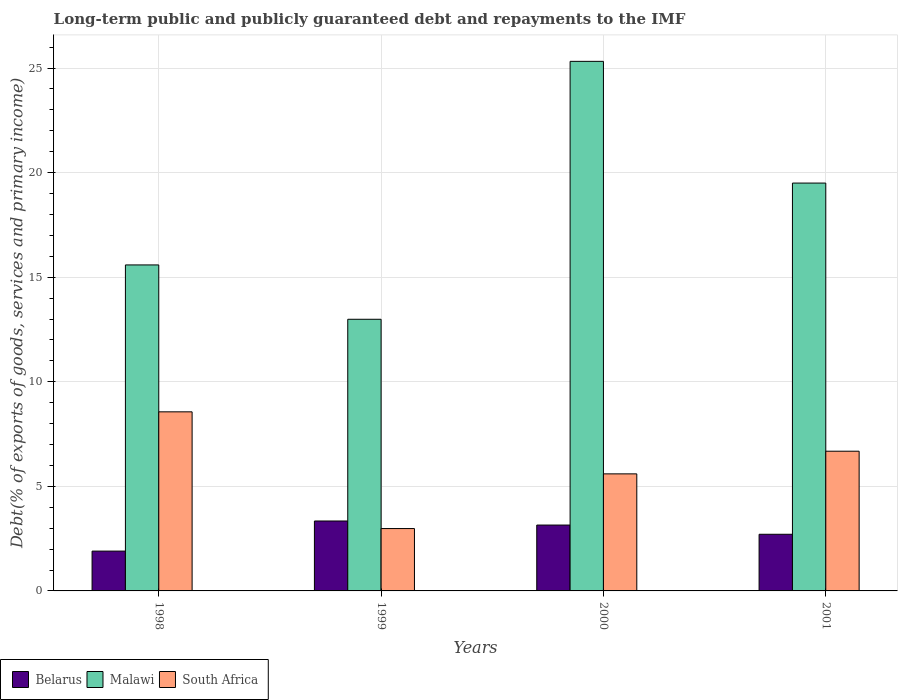How many different coloured bars are there?
Keep it short and to the point. 3. How many groups of bars are there?
Offer a terse response. 4. Are the number of bars per tick equal to the number of legend labels?
Make the answer very short. Yes. In how many cases, is the number of bars for a given year not equal to the number of legend labels?
Offer a very short reply. 0. What is the debt and repayments in South Africa in 2001?
Give a very brief answer. 6.68. Across all years, what is the maximum debt and repayments in Malawi?
Ensure brevity in your answer.  25.32. Across all years, what is the minimum debt and repayments in Belarus?
Keep it short and to the point. 1.9. In which year was the debt and repayments in South Africa maximum?
Give a very brief answer. 1998. What is the total debt and repayments in South Africa in the graph?
Keep it short and to the point. 23.82. What is the difference between the debt and repayments in South Africa in 1999 and that in 2001?
Ensure brevity in your answer.  -3.7. What is the difference between the debt and repayments in South Africa in 2000 and the debt and repayments in Malawi in 2001?
Make the answer very short. -13.9. What is the average debt and repayments in Belarus per year?
Offer a very short reply. 2.78. In the year 2001, what is the difference between the debt and repayments in South Africa and debt and repayments in Malawi?
Your answer should be very brief. -12.82. What is the ratio of the debt and repayments in Malawi in 2000 to that in 2001?
Offer a very short reply. 1.3. Is the difference between the debt and repayments in South Africa in 1999 and 2000 greater than the difference between the debt and repayments in Malawi in 1999 and 2000?
Provide a succinct answer. Yes. What is the difference between the highest and the second highest debt and repayments in Malawi?
Provide a short and direct response. 5.82. What is the difference between the highest and the lowest debt and repayments in Belarus?
Your answer should be compact. 1.44. What does the 3rd bar from the left in 2001 represents?
Your response must be concise. South Africa. What does the 3rd bar from the right in 1999 represents?
Ensure brevity in your answer.  Belarus. How many bars are there?
Offer a terse response. 12. How are the legend labels stacked?
Offer a terse response. Horizontal. What is the title of the graph?
Your response must be concise. Long-term public and publicly guaranteed debt and repayments to the IMF. What is the label or title of the X-axis?
Offer a terse response. Years. What is the label or title of the Y-axis?
Offer a very short reply. Debt(% of exports of goods, services and primary income). What is the Debt(% of exports of goods, services and primary income) of Belarus in 1998?
Your answer should be very brief. 1.9. What is the Debt(% of exports of goods, services and primary income) of Malawi in 1998?
Give a very brief answer. 15.59. What is the Debt(% of exports of goods, services and primary income) in South Africa in 1998?
Your answer should be very brief. 8.56. What is the Debt(% of exports of goods, services and primary income) of Belarus in 1999?
Provide a succinct answer. 3.34. What is the Debt(% of exports of goods, services and primary income) of Malawi in 1999?
Make the answer very short. 12.99. What is the Debt(% of exports of goods, services and primary income) of South Africa in 1999?
Provide a short and direct response. 2.98. What is the Debt(% of exports of goods, services and primary income) in Belarus in 2000?
Your answer should be compact. 3.15. What is the Debt(% of exports of goods, services and primary income) in Malawi in 2000?
Keep it short and to the point. 25.32. What is the Debt(% of exports of goods, services and primary income) in South Africa in 2000?
Your answer should be very brief. 5.6. What is the Debt(% of exports of goods, services and primary income) in Belarus in 2001?
Your answer should be very brief. 2.71. What is the Debt(% of exports of goods, services and primary income) of Malawi in 2001?
Provide a short and direct response. 19.5. What is the Debt(% of exports of goods, services and primary income) of South Africa in 2001?
Offer a terse response. 6.68. Across all years, what is the maximum Debt(% of exports of goods, services and primary income) in Belarus?
Keep it short and to the point. 3.34. Across all years, what is the maximum Debt(% of exports of goods, services and primary income) of Malawi?
Offer a terse response. 25.32. Across all years, what is the maximum Debt(% of exports of goods, services and primary income) in South Africa?
Make the answer very short. 8.56. Across all years, what is the minimum Debt(% of exports of goods, services and primary income) in Belarus?
Provide a succinct answer. 1.9. Across all years, what is the minimum Debt(% of exports of goods, services and primary income) of Malawi?
Offer a terse response. 12.99. Across all years, what is the minimum Debt(% of exports of goods, services and primary income) in South Africa?
Make the answer very short. 2.98. What is the total Debt(% of exports of goods, services and primary income) of Belarus in the graph?
Give a very brief answer. 11.11. What is the total Debt(% of exports of goods, services and primary income) of Malawi in the graph?
Give a very brief answer. 73.4. What is the total Debt(% of exports of goods, services and primary income) in South Africa in the graph?
Your response must be concise. 23.82. What is the difference between the Debt(% of exports of goods, services and primary income) of Belarus in 1998 and that in 1999?
Your answer should be compact. -1.44. What is the difference between the Debt(% of exports of goods, services and primary income) of Malawi in 1998 and that in 1999?
Your answer should be compact. 2.6. What is the difference between the Debt(% of exports of goods, services and primary income) in South Africa in 1998 and that in 1999?
Your answer should be very brief. 5.58. What is the difference between the Debt(% of exports of goods, services and primary income) of Belarus in 1998 and that in 2000?
Your answer should be compact. -1.25. What is the difference between the Debt(% of exports of goods, services and primary income) of Malawi in 1998 and that in 2000?
Your response must be concise. -9.73. What is the difference between the Debt(% of exports of goods, services and primary income) in South Africa in 1998 and that in 2000?
Offer a terse response. 2.97. What is the difference between the Debt(% of exports of goods, services and primary income) in Belarus in 1998 and that in 2001?
Your response must be concise. -0.8. What is the difference between the Debt(% of exports of goods, services and primary income) in Malawi in 1998 and that in 2001?
Your response must be concise. -3.91. What is the difference between the Debt(% of exports of goods, services and primary income) of South Africa in 1998 and that in 2001?
Your answer should be compact. 1.88. What is the difference between the Debt(% of exports of goods, services and primary income) of Belarus in 1999 and that in 2000?
Keep it short and to the point. 0.19. What is the difference between the Debt(% of exports of goods, services and primary income) of Malawi in 1999 and that in 2000?
Provide a short and direct response. -12.33. What is the difference between the Debt(% of exports of goods, services and primary income) of South Africa in 1999 and that in 2000?
Your answer should be very brief. -2.61. What is the difference between the Debt(% of exports of goods, services and primary income) of Belarus in 1999 and that in 2001?
Provide a short and direct response. 0.63. What is the difference between the Debt(% of exports of goods, services and primary income) in Malawi in 1999 and that in 2001?
Ensure brevity in your answer.  -6.51. What is the difference between the Debt(% of exports of goods, services and primary income) in South Africa in 1999 and that in 2001?
Your response must be concise. -3.7. What is the difference between the Debt(% of exports of goods, services and primary income) in Belarus in 2000 and that in 2001?
Offer a terse response. 0.44. What is the difference between the Debt(% of exports of goods, services and primary income) of Malawi in 2000 and that in 2001?
Keep it short and to the point. 5.82. What is the difference between the Debt(% of exports of goods, services and primary income) in South Africa in 2000 and that in 2001?
Provide a succinct answer. -1.08. What is the difference between the Debt(% of exports of goods, services and primary income) in Belarus in 1998 and the Debt(% of exports of goods, services and primary income) in Malawi in 1999?
Provide a short and direct response. -11.08. What is the difference between the Debt(% of exports of goods, services and primary income) in Belarus in 1998 and the Debt(% of exports of goods, services and primary income) in South Africa in 1999?
Your answer should be compact. -1.08. What is the difference between the Debt(% of exports of goods, services and primary income) of Malawi in 1998 and the Debt(% of exports of goods, services and primary income) of South Africa in 1999?
Offer a very short reply. 12.6. What is the difference between the Debt(% of exports of goods, services and primary income) of Belarus in 1998 and the Debt(% of exports of goods, services and primary income) of Malawi in 2000?
Provide a succinct answer. -23.42. What is the difference between the Debt(% of exports of goods, services and primary income) in Belarus in 1998 and the Debt(% of exports of goods, services and primary income) in South Africa in 2000?
Offer a terse response. -3.69. What is the difference between the Debt(% of exports of goods, services and primary income) in Malawi in 1998 and the Debt(% of exports of goods, services and primary income) in South Africa in 2000?
Make the answer very short. 9.99. What is the difference between the Debt(% of exports of goods, services and primary income) of Belarus in 1998 and the Debt(% of exports of goods, services and primary income) of Malawi in 2001?
Offer a terse response. -17.6. What is the difference between the Debt(% of exports of goods, services and primary income) of Belarus in 1998 and the Debt(% of exports of goods, services and primary income) of South Africa in 2001?
Keep it short and to the point. -4.78. What is the difference between the Debt(% of exports of goods, services and primary income) of Malawi in 1998 and the Debt(% of exports of goods, services and primary income) of South Africa in 2001?
Make the answer very short. 8.91. What is the difference between the Debt(% of exports of goods, services and primary income) of Belarus in 1999 and the Debt(% of exports of goods, services and primary income) of Malawi in 2000?
Keep it short and to the point. -21.98. What is the difference between the Debt(% of exports of goods, services and primary income) of Belarus in 1999 and the Debt(% of exports of goods, services and primary income) of South Africa in 2000?
Provide a short and direct response. -2.25. What is the difference between the Debt(% of exports of goods, services and primary income) in Malawi in 1999 and the Debt(% of exports of goods, services and primary income) in South Africa in 2000?
Provide a short and direct response. 7.39. What is the difference between the Debt(% of exports of goods, services and primary income) of Belarus in 1999 and the Debt(% of exports of goods, services and primary income) of Malawi in 2001?
Your answer should be very brief. -16.16. What is the difference between the Debt(% of exports of goods, services and primary income) in Belarus in 1999 and the Debt(% of exports of goods, services and primary income) in South Africa in 2001?
Your answer should be very brief. -3.34. What is the difference between the Debt(% of exports of goods, services and primary income) of Malawi in 1999 and the Debt(% of exports of goods, services and primary income) of South Africa in 2001?
Provide a succinct answer. 6.31. What is the difference between the Debt(% of exports of goods, services and primary income) in Belarus in 2000 and the Debt(% of exports of goods, services and primary income) in Malawi in 2001?
Keep it short and to the point. -16.35. What is the difference between the Debt(% of exports of goods, services and primary income) of Belarus in 2000 and the Debt(% of exports of goods, services and primary income) of South Africa in 2001?
Offer a terse response. -3.53. What is the difference between the Debt(% of exports of goods, services and primary income) of Malawi in 2000 and the Debt(% of exports of goods, services and primary income) of South Africa in 2001?
Offer a terse response. 18.64. What is the average Debt(% of exports of goods, services and primary income) of Belarus per year?
Your response must be concise. 2.78. What is the average Debt(% of exports of goods, services and primary income) of Malawi per year?
Provide a succinct answer. 18.35. What is the average Debt(% of exports of goods, services and primary income) in South Africa per year?
Ensure brevity in your answer.  5.96. In the year 1998, what is the difference between the Debt(% of exports of goods, services and primary income) of Belarus and Debt(% of exports of goods, services and primary income) of Malawi?
Give a very brief answer. -13.68. In the year 1998, what is the difference between the Debt(% of exports of goods, services and primary income) in Belarus and Debt(% of exports of goods, services and primary income) in South Africa?
Your answer should be compact. -6.66. In the year 1998, what is the difference between the Debt(% of exports of goods, services and primary income) of Malawi and Debt(% of exports of goods, services and primary income) of South Africa?
Provide a succinct answer. 7.02. In the year 1999, what is the difference between the Debt(% of exports of goods, services and primary income) in Belarus and Debt(% of exports of goods, services and primary income) in Malawi?
Your answer should be compact. -9.65. In the year 1999, what is the difference between the Debt(% of exports of goods, services and primary income) in Belarus and Debt(% of exports of goods, services and primary income) in South Africa?
Your answer should be compact. 0.36. In the year 1999, what is the difference between the Debt(% of exports of goods, services and primary income) in Malawi and Debt(% of exports of goods, services and primary income) in South Africa?
Give a very brief answer. 10.01. In the year 2000, what is the difference between the Debt(% of exports of goods, services and primary income) in Belarus and Debt(% of exports of goods, services and primary income) in Malawi?
Provide a short and direct response. -22.17. In the year 2000, what is the difference between the Debt(% of exports of goods, services and primary income) in Belarus and Debt(% of exports of goods, services and primary income) in South Africa?
Provide a short and direct response. -2.45. In the year 2000, what is the difference between the Debt(% of exports of goods, services and primary income) of Malawi and Debt(% of exports of goods, services and primary income) of South Africa?
Your response must be concise. 19.72. In the year 2001, what is the difference between the Debt(% of exports of goods, services and primary income) of Belarus and Debt(% of exports of goods, services and primary income) of Malawi?
Offer a terse response. -16.79. In the year 2001, what is the difference between the Debt(% of exports of goods, services and primary income) of Belarus and Debt(% of exports of goods, services and primary income) of South Africa?
Your response must be concise. -3.97. In the year 2001, what is the difference between the Debt(% of exports of goods, services and primary income) in Malawi and Debt(% of exports of goods, services and primary income) in South Africa?
Give a very brief answer. 12.82. What is the ratio of the Debt(% of exports of goods, services and primary income) of Belarus in 1998 to that in 1999?
Your response must be concise. 0.57. What is the ratio of the Debt(% of exports of goods, services and primary income) in Malawi in 1998 to that in 1999?
Provide a succinct answer. 1.2. What is the ratio of the Debt(% of exports of goods, services and primary income) in South Africa in 1998 to that in 1999?
Give a very brief answer. 2.87. What is the ratio of the Debt(% of exports of goods, services and primary income) of Belarus in 1998 to that in 2000?
Make the answer very short. 0.6. What is the ratio of the Debt(% of exports of goods, services and primary income) of Malawi in 1998 to that in 2000?
Offer a very short reply. 0.62. What is the ratio of the Debt(% of exports of goods, services and primary income) of South Africa in 1998 to that in 2000?
Provide a succinct answer. 1.53. What is the ratio of the Debt(% of exports of goods, services and primary income) of Belarus in 1998 to that in 2001?
Provide a succinct answer. 0.7. What is the ratio of the Debt(% of exports of goods, services and primary income) in Malawi in 1998 to that in 2001?
Offer a very short reply. 0.8. What is the ratio of the Debt(% of exports of goods, services and primary income) of South Africa in 1998 to that in 2001?
Make the answer very short. 1.28. What is the ratio of the Debt(% of exports of goods, services and primary income) of Belarus in 1999 to that in 2000?
Offer a terse response. 1.06. What is the ratio of the Debt(% of exports of goods, services and primary income) in Malawi in 1999 to that in 2000?
Offer a terse response. 0.51. What is the ratio of the Debt(% of exports of goods, services and primary income) in South Africa in 1999 to that in 2000?
Keep it short and to the point. 0.53. What is the ratio of the Debt(% of exports of goods, services and primary income) in Belarus in 1999 to that in 2001?
Your answer should be very brief. 1.23. What is the ratio of the Debt(% of exports of goods, services and primary income) of Malawi in 1999 to that in 2001?
Ensure brevity in your answer.  0.67. What is the ratio of the Debt(% of exports of goods, services and primary income) of South Africa in 1999 to that in 2001?
Offer a terse response. 0.45. What is the ratio of the Debt(% of exports of goods, services and primary income) in Belarus in 2000 to that in 2001?
Keep it short and to the point. 1.16. What is the ratio of the Debt(% of exports of goods, services and primary income) in Malawi in 2000 to that in 2001?
Offer a very short reply. 1.3. What is the ratio of the Debt(% of exports of goods, services and primary income) of South Africa in 2000 to that in 2001?
Your response must be concise. 0.84. What is the difference between the highest and the second highest Debt(% of exports of goods, services and primary income) in Belarus?
Provide a succinct answer. 0.19. What is the difference between the highest and the second highest Debt(% of exports of goods, services and primary income) in Malawi?
Ensure brevity in your answer.  5.82. What is the difference between the highest and the second highest Debt(% of exports of goods, services and primary income) in South Africa?
Provide a short and direct response. 1.88. What is the difference between the highest and the lowest Debt(% of exports of goods, services and primary income) of Belarus?
Your response must be concise. 1.44. What is the difference between the highest and the lowest Debt(% of exports of goods, services and primary income) in Malawi?
Your answer should be compact. 12.33. What is the difference between the highest and the lowest Debt(% of exports of goods, services and primary income) of South Africa?
Offer a very short reply. 5.58. 